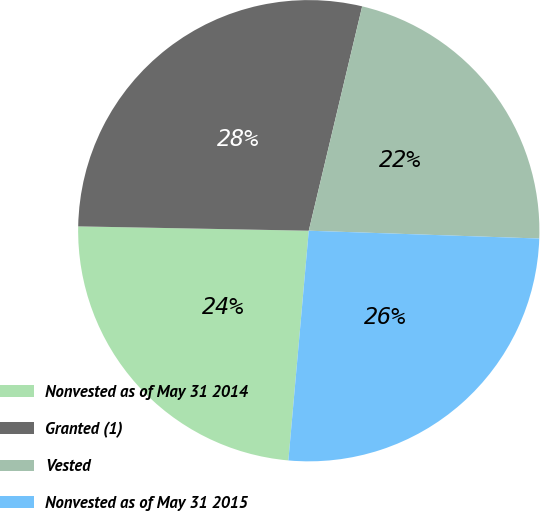Convert chart. <chart><loc_0><loc_0><loc_500><loc_500><pie_chart><fcel>Nonvested as of May 31 2014<fcel>Granted (1)<fcel>Vested<fcel>Nonvested as of May 31 2015<nl><fcel>23.89%<fcel>28.42%<fcel>21.82%<fcel>25.87%<nl></chart> 